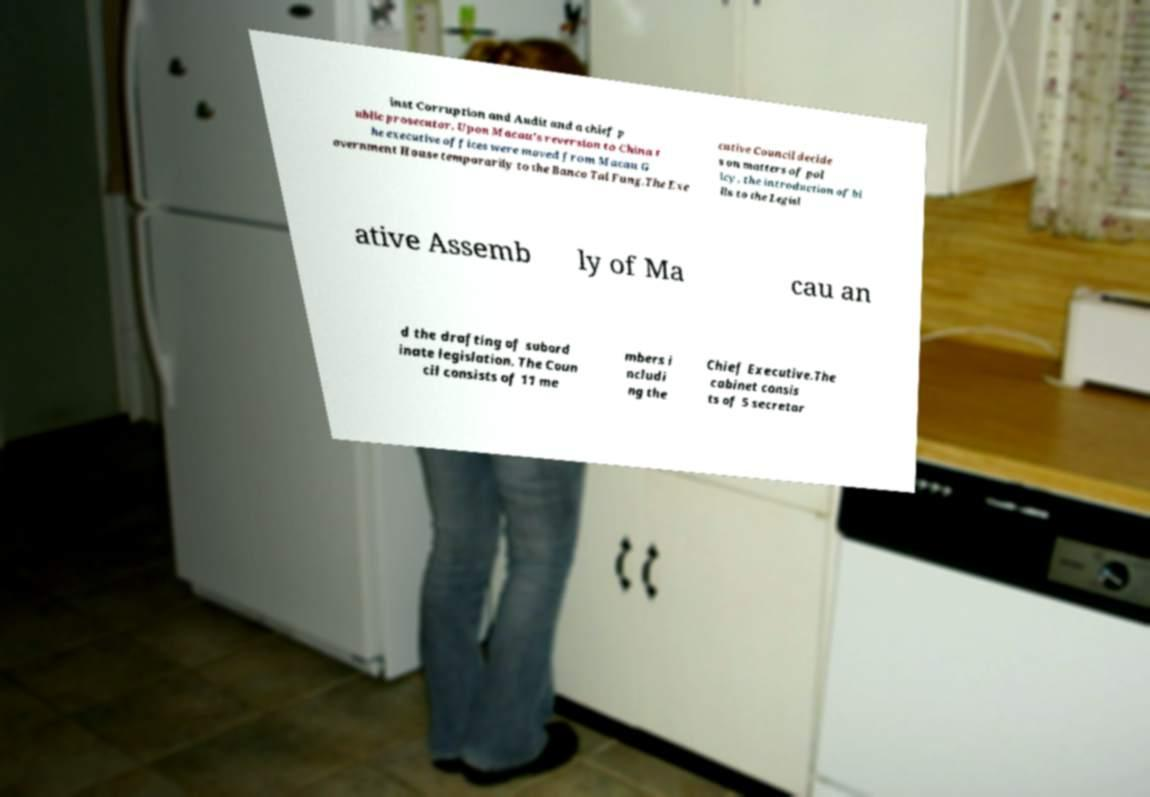Could you extract and type out the text from this image? inst Corruption and Audit and a chief p ublic prosecutor. Upon Macau's reversion to China t he executive offices were moved from Macau G overnment House temporarily to the Banco Tai Fung.The Exe cutive Council decide s on matters of pol icy, the introduction of bi lls to the Legisl ative Assemb ly of Ma cau an d the drafting of subord inate legislation. The Coun cil consists of 11 me mbers i ncludi ng the Chief Executive.The cabinet consis ts of 5 secretar 